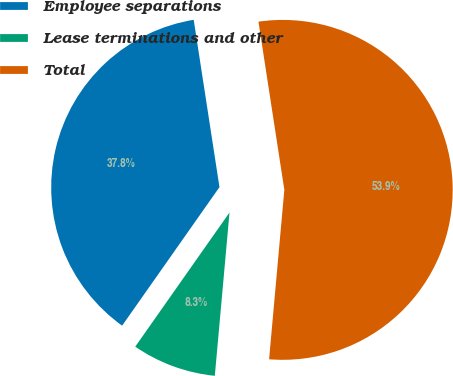Convert chart to OTSL. <chart><loc_0><loc_0><loc_500><loc_500><pie_chart><fcel>Employee separations<fcel>Lease terminations and other<fcel>Total<nl><fcel>37.82%<fcel>8.32%<fcel>53.86%<nl></chart> 